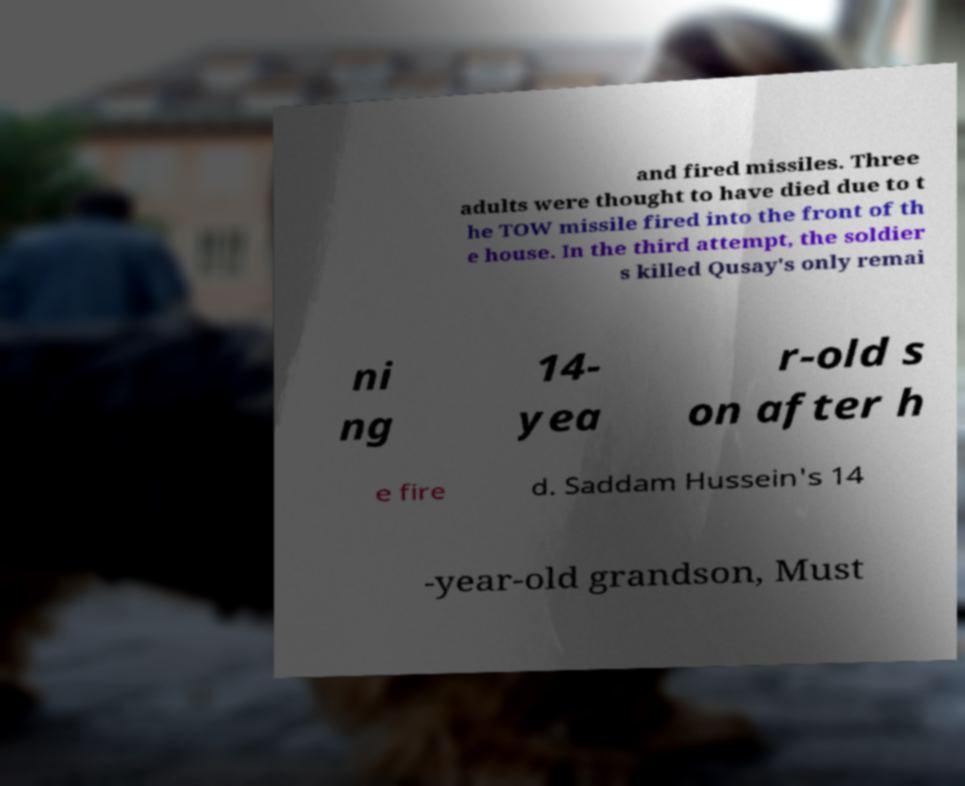Could you assist in decoding the text presented in this image and type it out clearly? and fired missiles. Three adults were thought to have died due to t he TOW missile fired into the front of th e house. In the third attempt, the soldier s killed Qusay's only remai ni ng 14- yea r-old s on after h e fire d. Saddam Hussein's 14 -year-old grandson, Must 